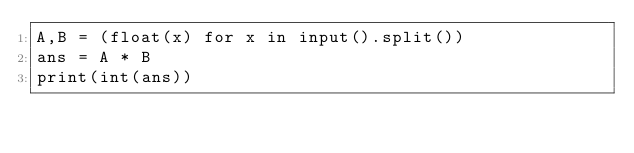Convert code to text. <code><loc_0><loc_0><loc_500><loc_500><_Python_>A,B = (float(x) for x in input().split())
ans = A * B
print(int(ans))</code> 